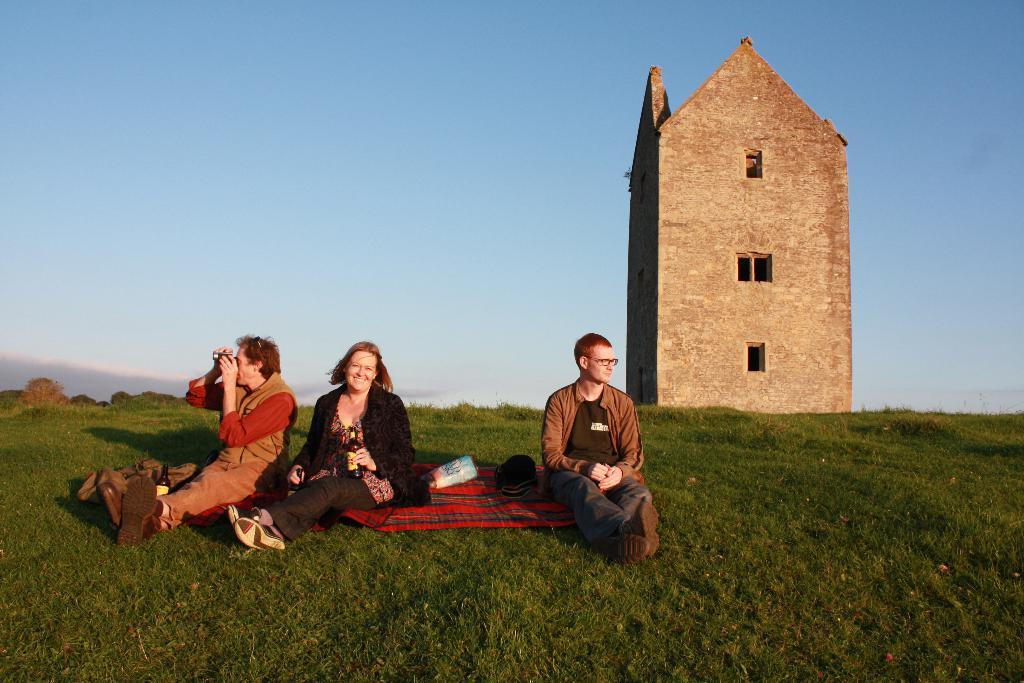How many people are in the image? There are three people in the image. What are the people doing in the image? The people are sitting on the grass. What can be seen in the background of the image? There is some architecture visible in the background of the image. What type of thread is being used to hold the pancake in the image? There is no pancake or thread present in the image. How does the grip of the people sitting on the grass affect their posture in the image? The provided facts do not mention the grip of the people sitting on the grass, so we cannot determine how it affects their posture. 